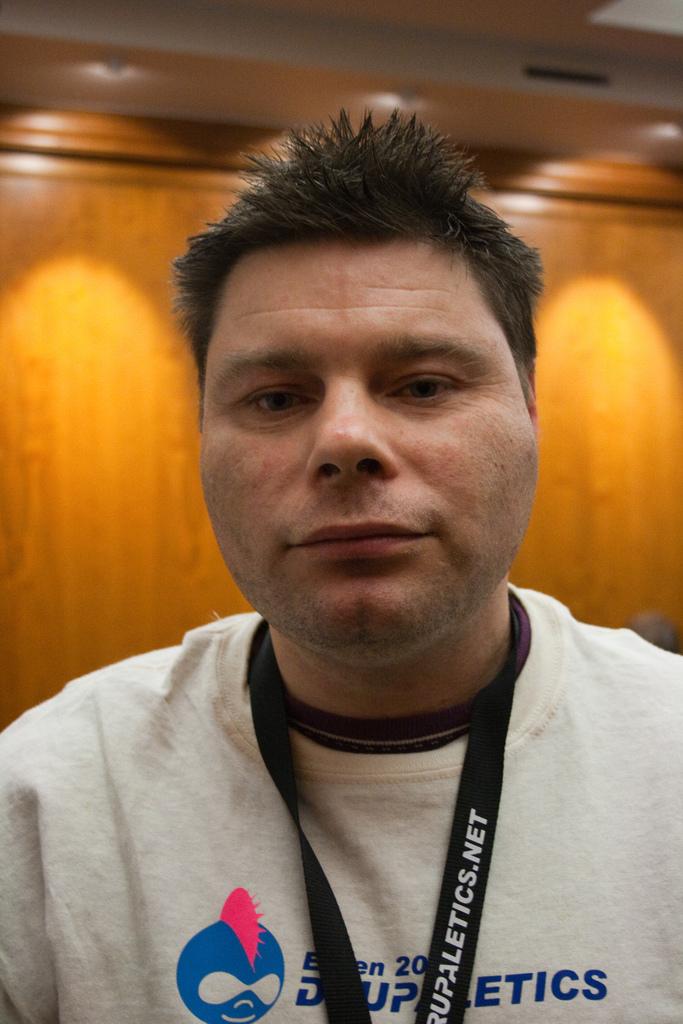Does the website end in .net or .com?
Your answer should be very brief. .net. What's the name of the website?
Offer a very short reply. Rupaletics.net. 